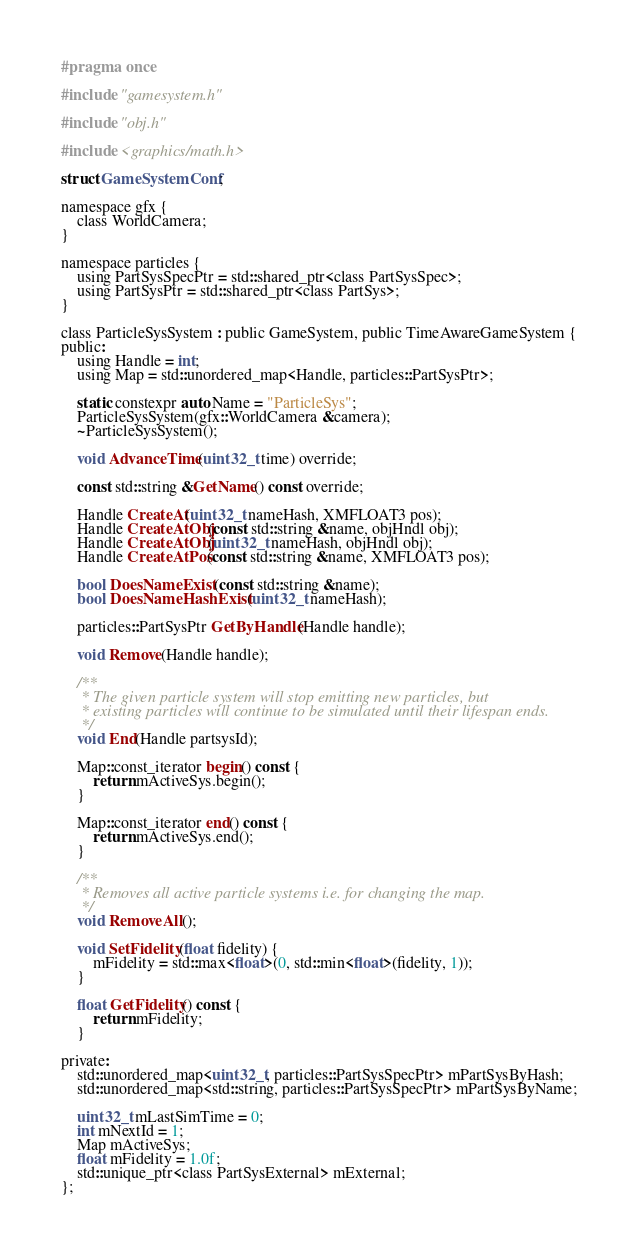<code> <loc_0><loc_0><loc_500><loc_500><_C_>
#pragma once

#include "gamesystem.h"

#include "obj.h"

#include <graphics/math.h>

struct GameSystemConf;

namespace gfx {
	class WorldCamera;
}

namespace particles {
	using PartSysSpecPtr = std::shared_ptr<class PartSysSpec>;
	using PartSysPtr = std::shared_ptr<class PartSys>;
}

class ParticleSysSystem : public GameSystem, public TimeAwareGameSystem {
public:
	using Handle = int;
	using Map = std::unordered_map<Handle, particles::PartSysPtr>;

	static constexpr auto Name = "ParticleSys";
	ParticleSysSystem(gfx::WorldCamera &camera);
	~ParticleSysSystem();

	void AdvanceTime(uint32_t time) override;

	const std::string &GetName() const override;

	Handle CreateAt(uint32_t nameHash, XMFLOAT3 pos);
	Handle CreateAtObj(const std::string &name, objHndl obj);
	Handle CreateAtObj(uint32_t nameHash, objHndl obj);
	Handle CreateAtPos(const std::string &name, XMFLOAT3 pos);

	bool DoesNameExist(const std::string &name);
	bool DoesNameHashExist(uint32_t nameHash);

	particles::PartSysPtr GetByHandle(Handle handle);

	void Remove(Handle handle);

	/**
	 * The given particle system will stop emitting new particles, but
	 * existing particles will continue to be simulated until their lifespan ends.
	 */
	void End(Handle partsysId);

	Map::const_iterator begin() const {
		return mActiveSys.begin();
	}

	Map::const_iterator end() const {
		return mActiveSys.end();
	}

	/**
	 * Removes all active particle systems i.e. for changing the map.
	 */
	void RemoveAll();

	void SetFidelity(float fidelity) {
		mFidelity = std::max<float>(0, std::min<float>(fidelity, 1));
	}

	float GetFidelity() const {
		return mFidelity;
	}

private:
	std::unordered_map<uint32_t, particles::PartSysSpecPtr> mPartSysByHash;
	std::unordered_map<std::string, particles::PartSysSpecPtr> mPartSysByName;

	uint32_t mLastSimTime = 0;
	int mNextId = 1;
	Map mActiveSys;
	float mFidelity = 1.0f;
	std::unique_ptr<class PartSysExternal> mExternal;
};
</code> 